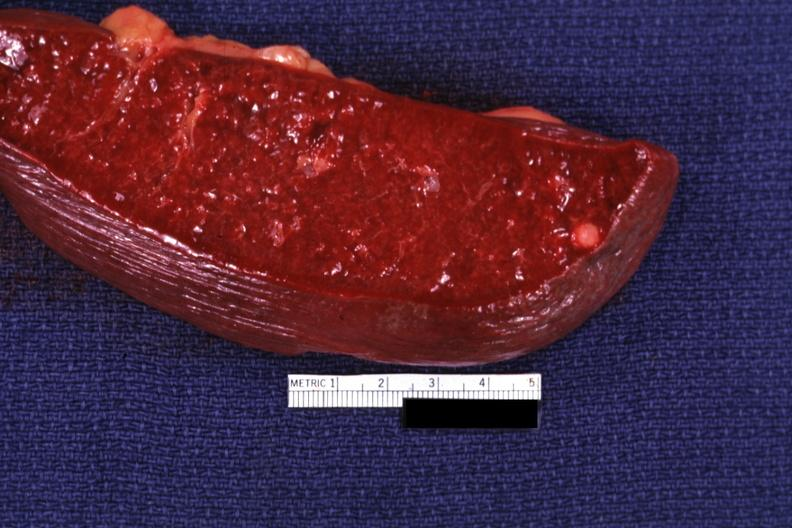what is present?
Answer the question using a single word or phrase. Hematologic 